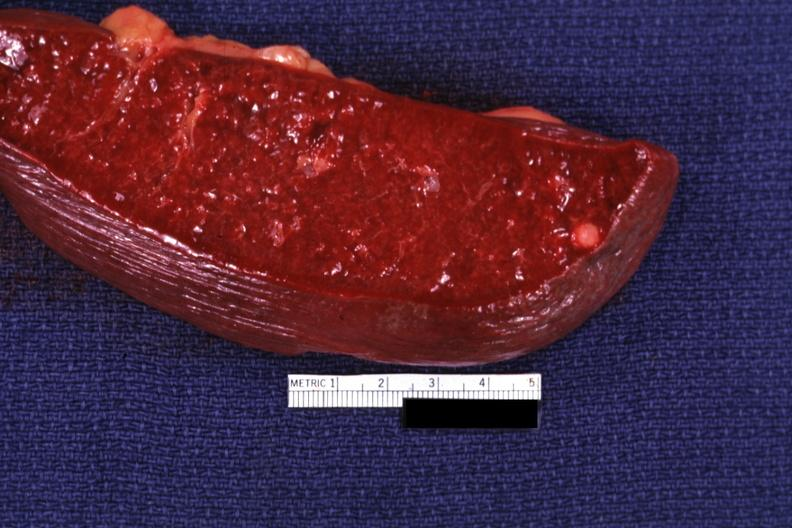what is present?
Answer the question using a single word or phrase. Hematologic 